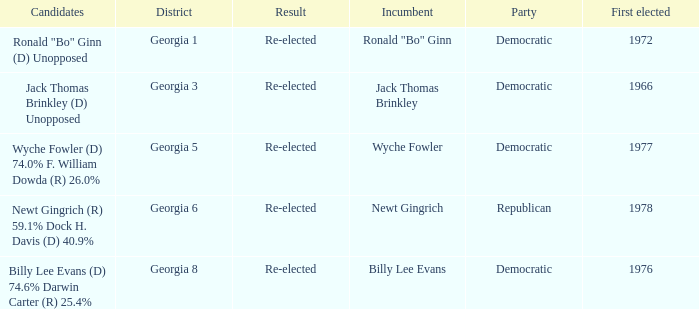How many candidates were first elected in 1972? 1.0. 